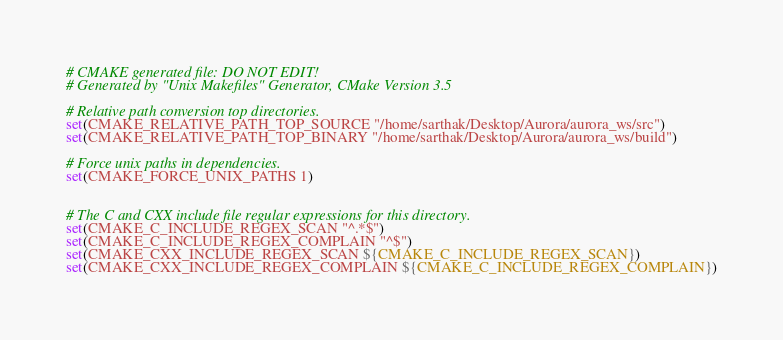<code> <loc_0><loc_0><loc_500><loc_500><_CMake_># CMAKE generated file: DO NOT EDIT!
# Generated by "Unix Makefiles" Generator, CMake Version 3.5

# Relative path conversion top directories.
set(CMAKE_RELATIVE_PATH_TOP_SOURCE "/home/sarthak/Desktop/Aurora/aurora_ws/src")
set(CMAKE_RELATIVE_PATH_TOP_BINARY "/home/sarthak/Desktop/Aurora/aurora_ws/build")

# Force unix paths in dependencies.
set(CMAKE_FORCE_UNIX_PATHS 1)


# The C and CXX include file regular expressions for this directory.
set(CMAKE_C_INCLUDE_REGEX_SCAN "^.*$")
set(CMAKE_C_INCLUDE_REGEX_COMPLAIN "^$")
set(CMAKE_CXX_INCLUDE_REGEX_SCAN ${CMAKE_C_INCLUDE_REGEX_SCAN})
set(CMAKE_CXX_INCLUDE_REGEX_COMPLAIN ${CMAKE_C_INCLUDE_REGEX_COMPLAIN})
</code> 